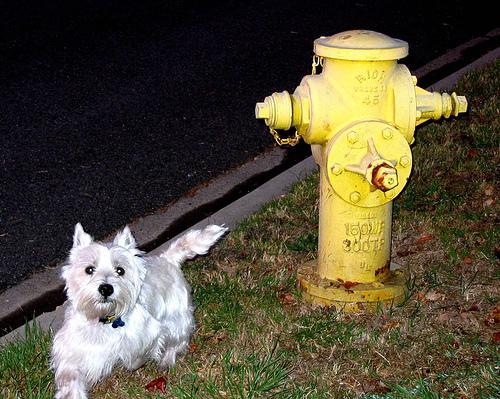Question: when was the photo taken?
Choices:
A. During the day.
B. Morning.
C. At night.
D. Evening.
Answer with the letter. Answer: C Question: what is around the dog's neck?
Choices:
A. A leash.
B. A red collar.
C. A pink collar.
D. Collar.
Answer with the letter. Answer: D Question: how many dogs are there?
Choices:
A. Two.
B. Three.
C. Four.
D. One.
Answer with the letter. Answer: D Question: what color is the grass?
Choices:
A. Yellow and orange.
B. Black and grey.
C. Red and amber.
D. Brown and green.
Answer with the letter. Answer: D 